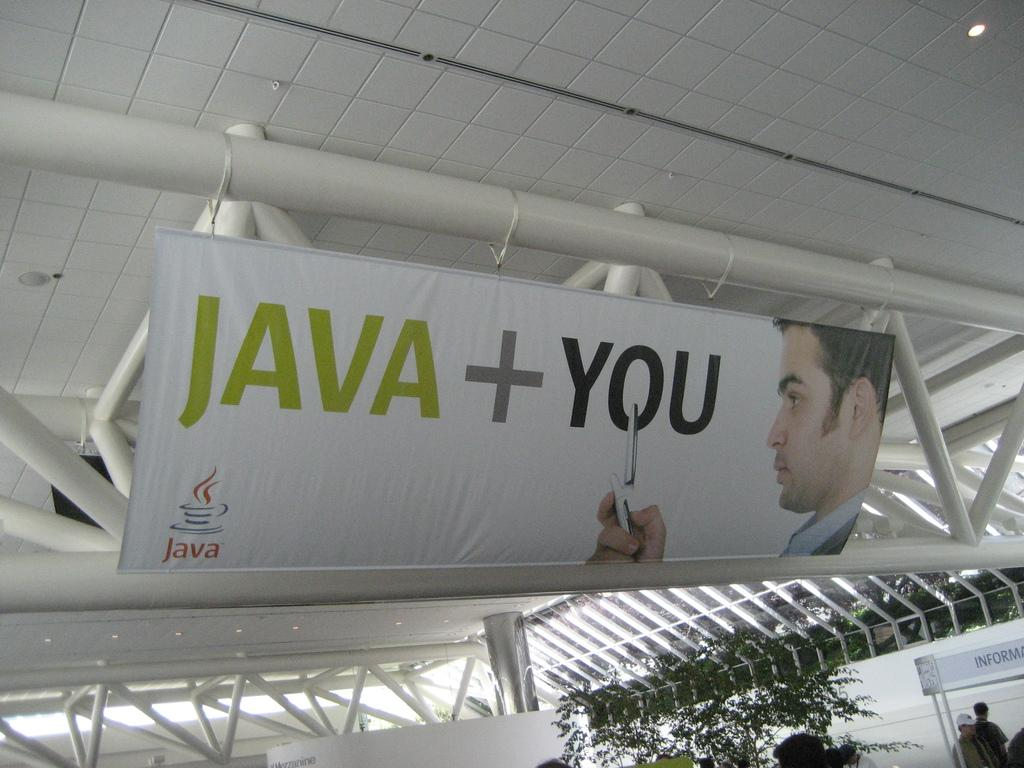Provide a one-sentence caption for the provided image. sign poster that reads java+ you with a cellphone. 